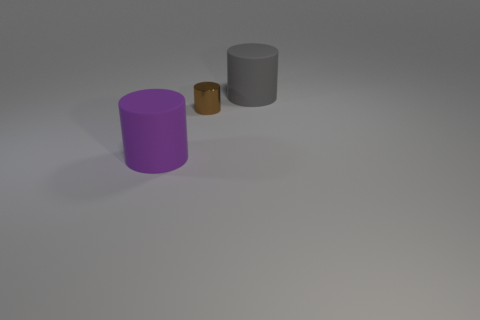Are there more big objects than metal cylinders?
Keep it short and to the point. Yes. What number of cylinders are both to the right of the large purple matte cylinder and in front of the large gray cylinder?
Your answer should be compact. 1. What shape is the matte object that is to the right of the rubber object that is to the left of the big gray rubber thing behind the purple rubber cylinder?
Your response must be concise. Cylinder. Are there any other things that are the same shape as the big gray thing?
Your answer should be very brief. Yes. How many blocks are red metallic objects or purple objects?
Provide a succinct answer. 0. There is a large thing that is behind the big rubber cylinder that is in front of the large matte cylinder behind the small brown shiny thing; what is it made of?
Keep it short and to the point. Rubber. Is the size of the purple rubber thing the same as the brown object?
Offer a terse response. No. What is the shape of the purple thing that is made of the same material as the large gray thing?
Ensure brevity in your answer.  Cylinder. What size is the rubber cylinder to the right of the large cylinder in front of the big gray matte cylinder?
Keep it short and to the point. Large. What color is the large thing that is the same material as the purple cylinder?
Give a very brief answer. Gray. 